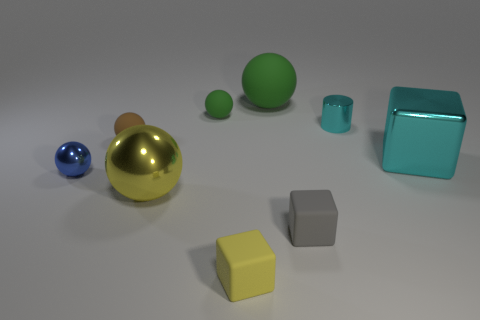Subtract all blue metallic spheres. How many spheres are left? 4 Subtract all yellow balls. How many balls are left? 4 Subtract all cyan balls. Subtract all brown blocks. How many balls are left? 5 Add 1 blue metallic balls. How many objects exist? 10 Subtract all balls. How many objects are left? 4 Add 7 tiny red things. How many tiny red things exist? 7 Subtract 0 yellow cylinders. How many objects are left? 9 Subtract all brown spheres. Subtract all large cyan things. How many objects are left? 7 Add 2 tiny gray matte things. How many tiny gray matte things are left? 3 